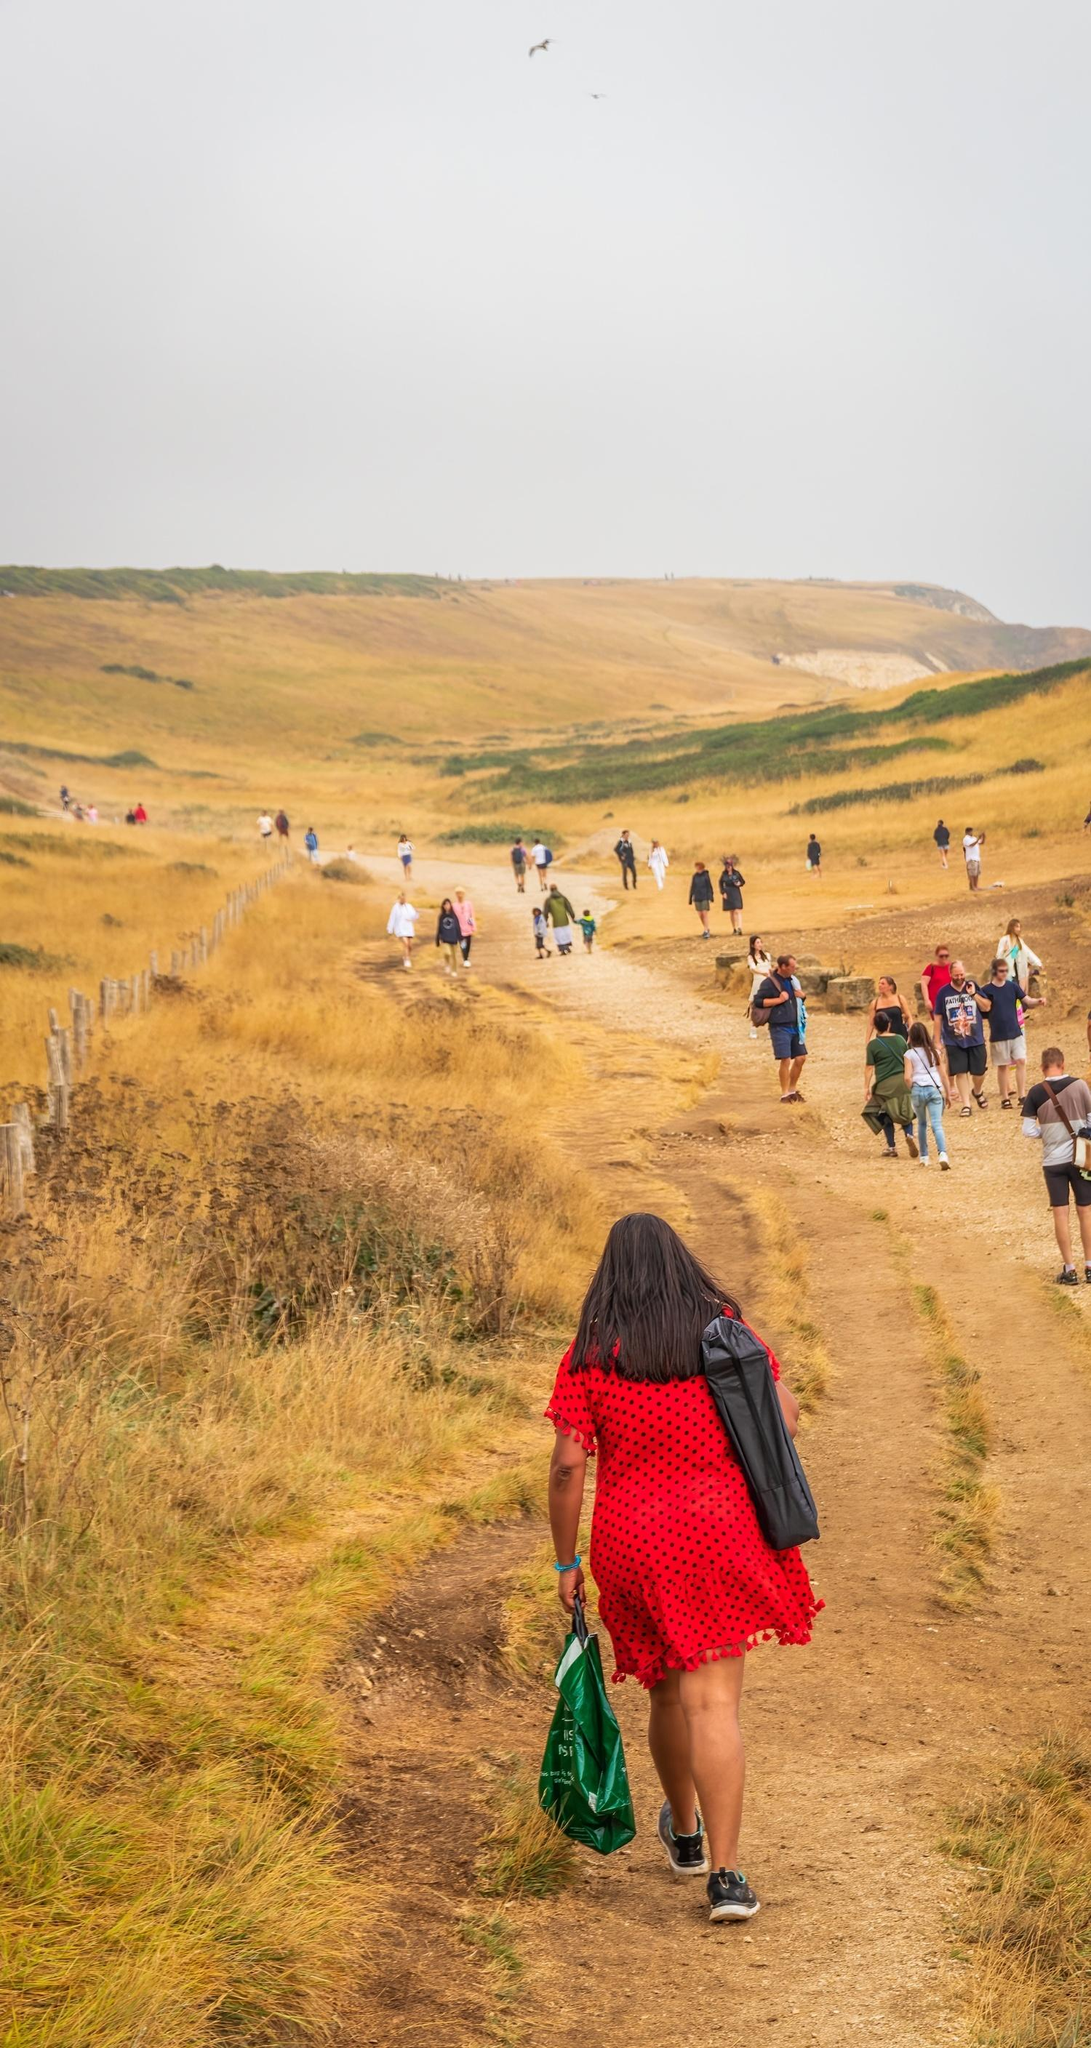What might be the destination or purpose of the group's walk? The purpose of the group's walk might be a recreational hike, a nature expedition, or a communal event like a group picnic or an organized countryside walk. The relaxed pace and casual demeanor of the people suggest they are out to enjoy the natural scenery, bond with each other, and perhaps reach a scenic viewpoint or a special spot along the trail. What could be some of the conversations happening among the group? Conversations among the group might include discussions about the beautiful landscape, planning future outings, sharing personal stories or experiences, talking about work or family, and maybe even joking and laughing about past adventures. Some might also be marveling at the wildlife or sharing interesting facts about the area they're exploring. 